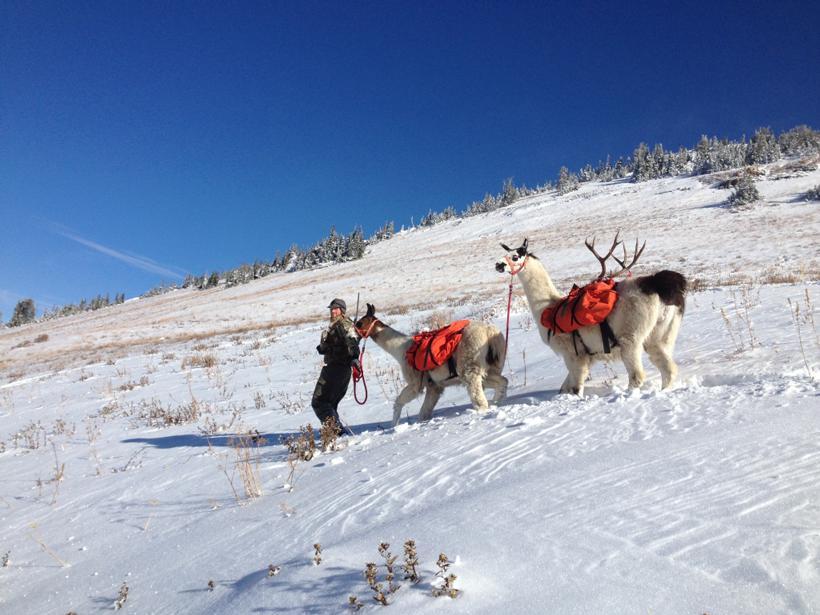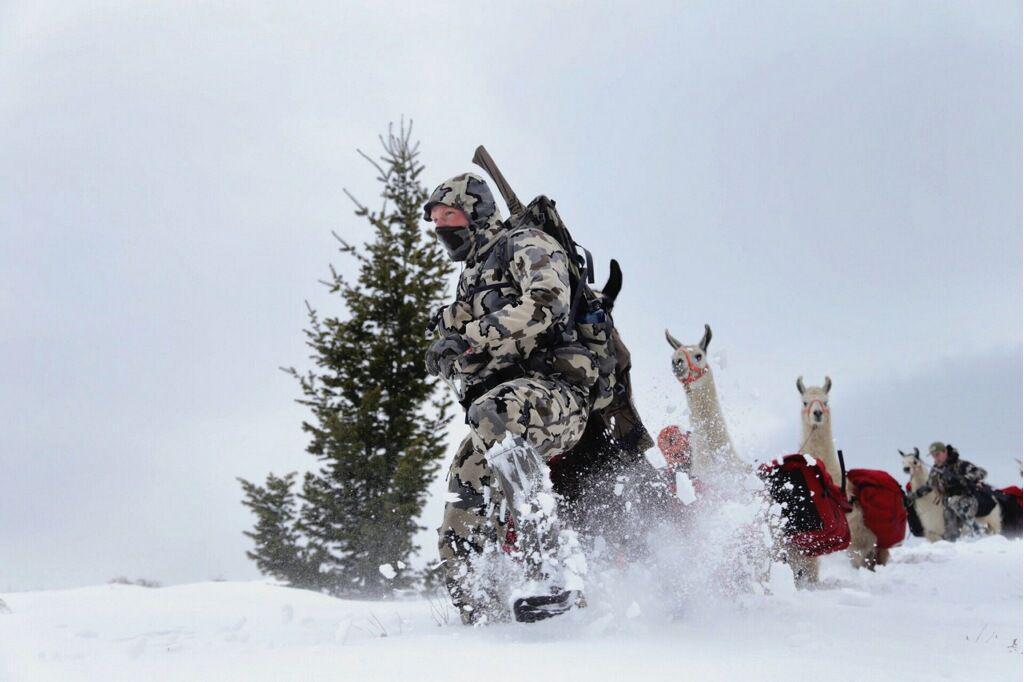The first image is the image on the left, the second image is the image on the right. Analyze the images presented: Is the assertion "The landscape shows a cloudy blue sky on the left image." valid? Answer yes or no. No. The first image is the image on the left, the second image is the image on the right. For the images shown, is this caption "There is a man in camouflage leading a pack of llamas through the snow, the llamas are wearing packs on their backs" true? Answer yes or no. Yes. 